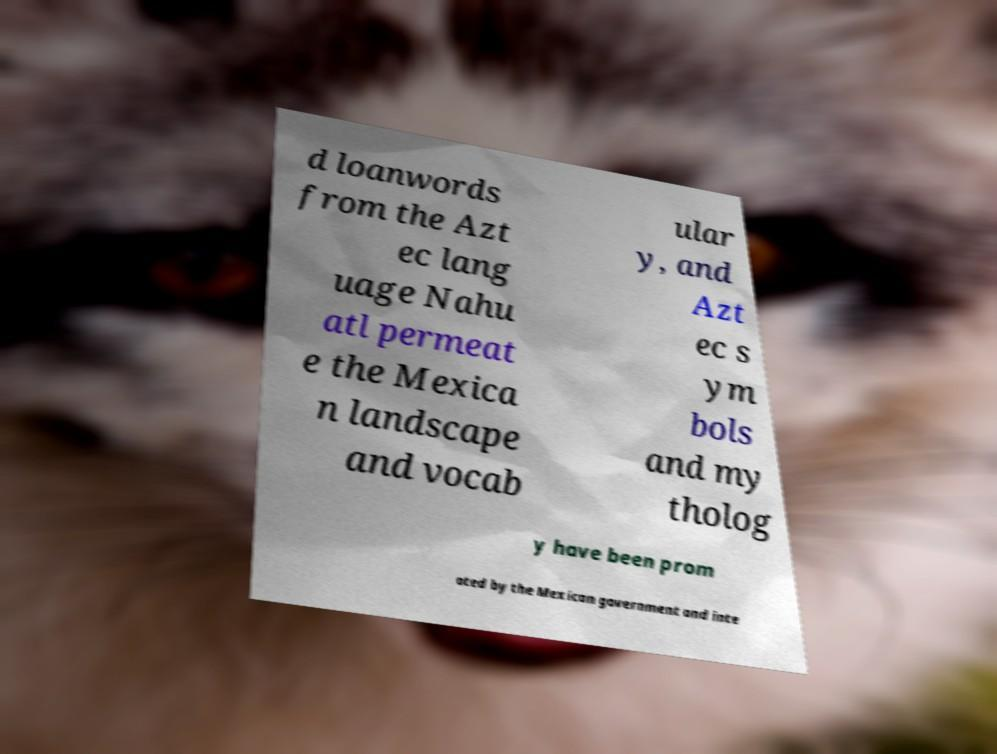Please read and relay the text visible in this image. What does it say? d loanwords from the Azt ec lang uage Nahu atl permeat e the Mexica n landscape and vocab ular y, and Azt ec s ym bols and my tholog y have been prom oted by the Mexican government and inte 